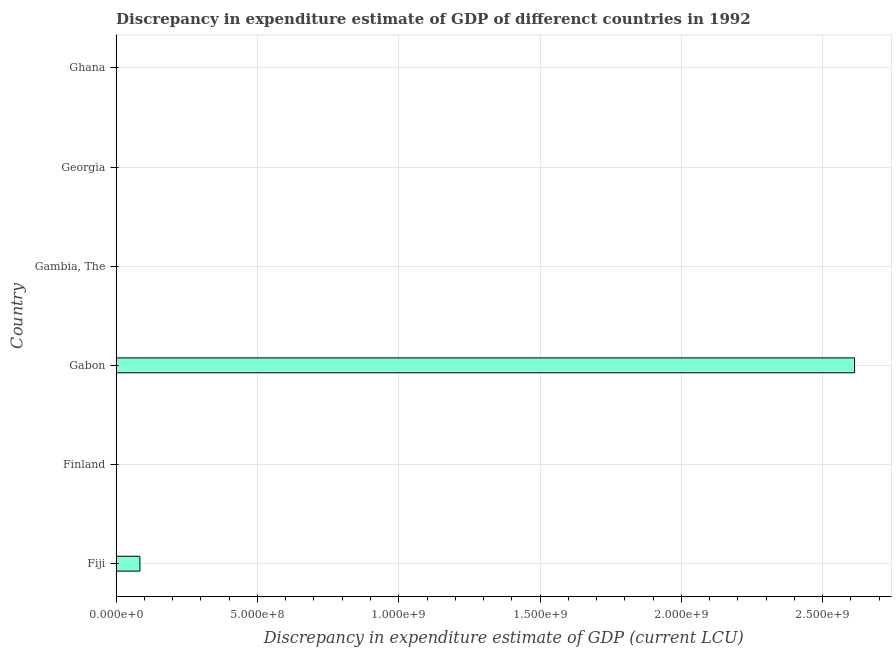What is the title of the graph?
Offer a very short reply. Discrepancy in expenditure estimate of GDP of differenct countries in 1992. What is the label or title of the X-axis?
Your answer should be compact. Discrepancy in expenditure estimate of GDP (current LCU). What is the discrepancy in expenditure estimate of gdp in Gambia, The?
Make the answer very short. 0. Across all countries, what is the maximum discrepancy in expenditure estimate of gdp?
Keep it short and to the point. 2.61e+09. Across all countries, what is the minimum discrepancy in expenditure estimate of gdp?
Give a very brief answer. 0. In which country was the discrepancy in expenditure estimate of gdp maximum?
Give a very brief answer. Gabon. What is the sum of the discrepancy in expenditure estimate of gdp?
Your answer should be compact. 2.70e+09. What is the difference between the discrepancy in expenditure estimate of gdp in Fiji and Georgia?
Your response must be concise. 8.40e+07. What is the average discrepancy in expenditure estimate of gdp per country?
Ensure brevity in your answer.  4.50e+08. What is the median discrepancy in expenditure estimate of gdp?
Your answer should be compact. 9650. In how many countries, is the discrepancy in expenditure estimate of gdp greater than 2200000000 LCU?
Your answer should be very brief. 1. What is the ratio of the discrepancy in expenditure estimate of gdp in Fiji to that in Gabon?
Offer a very short reply. 0.03. What is the difference between the highest and the second highest discrepancy in expenditure estimate of gdp?
Offer a terse response. 2.53e+09. What is the difference between the highest and the lowest discrepancy in expenditure estimate of gdp?
Offer a terse response. 2.61e+09. In how many countries, is the discrepancy in expenditure estimate of gdp greater than the average discrepancy in expenditure estimate of gdp taken over all countries?
Give a very brief answer. 1. Are all the bars in the graph horizontal?
Your response must be concise. Yes. How many countries are there in the graph?
Provide a succinct answer. 6. Are the values on the major ticks of X-axis written in scientific E-notation?
Make the answer very short. Yes. What is the Discrepancy in expenditure estimate of GDP (current LCU) of Fiji?
Offer a very short reply. 8.41e+07. What is the Discrepancy in expenditure estimate of GDP (current LCU) in Gabon?
Your answer should be very brief. 2.61e+09. What is the Discrepancy in expenditure estimate of GDP (current LCU) of Gambia, The?
Offer a very short reply. 0. What is the Discrepancy in expenditure estimate of GDP (current LCU) of Georgia?
Your response must be concise. 1.93e+04. What is the difference between the Discrepancy in expenditure estimate of GDP (current LCU) in Fiji and Gabon?
Your answer should be very brief. -2.53e+09. What is the difference between the Discrepancy in expenditure estimate of GDP (current LCU) in Fiji and Georgia?
Provide a succinct answer. 8.40e+07. What is the difference between the Discrepancy in expenditure estimate of GDP (current LCU) in Gabon and Georgia?
Ensure brevity in your answer.  2.61e+09. What is the ratio of the Discrepancy in expenditure estimate of GDP (current LCU) in Fiji to that in Gabon?
Offer a terse response. 0.03. What is the ratio of the Discrepancy in expenditure estimate of GDP (current LCU) in Fiji to that in Georgia?
Your answer should be very brief. 4355.03. What is the ratio of the Discrepancy in expenditure estimate of GDP (current LCU) in Gabon to that in Georgia?
Give a very brief answer. 1.35e+05. 